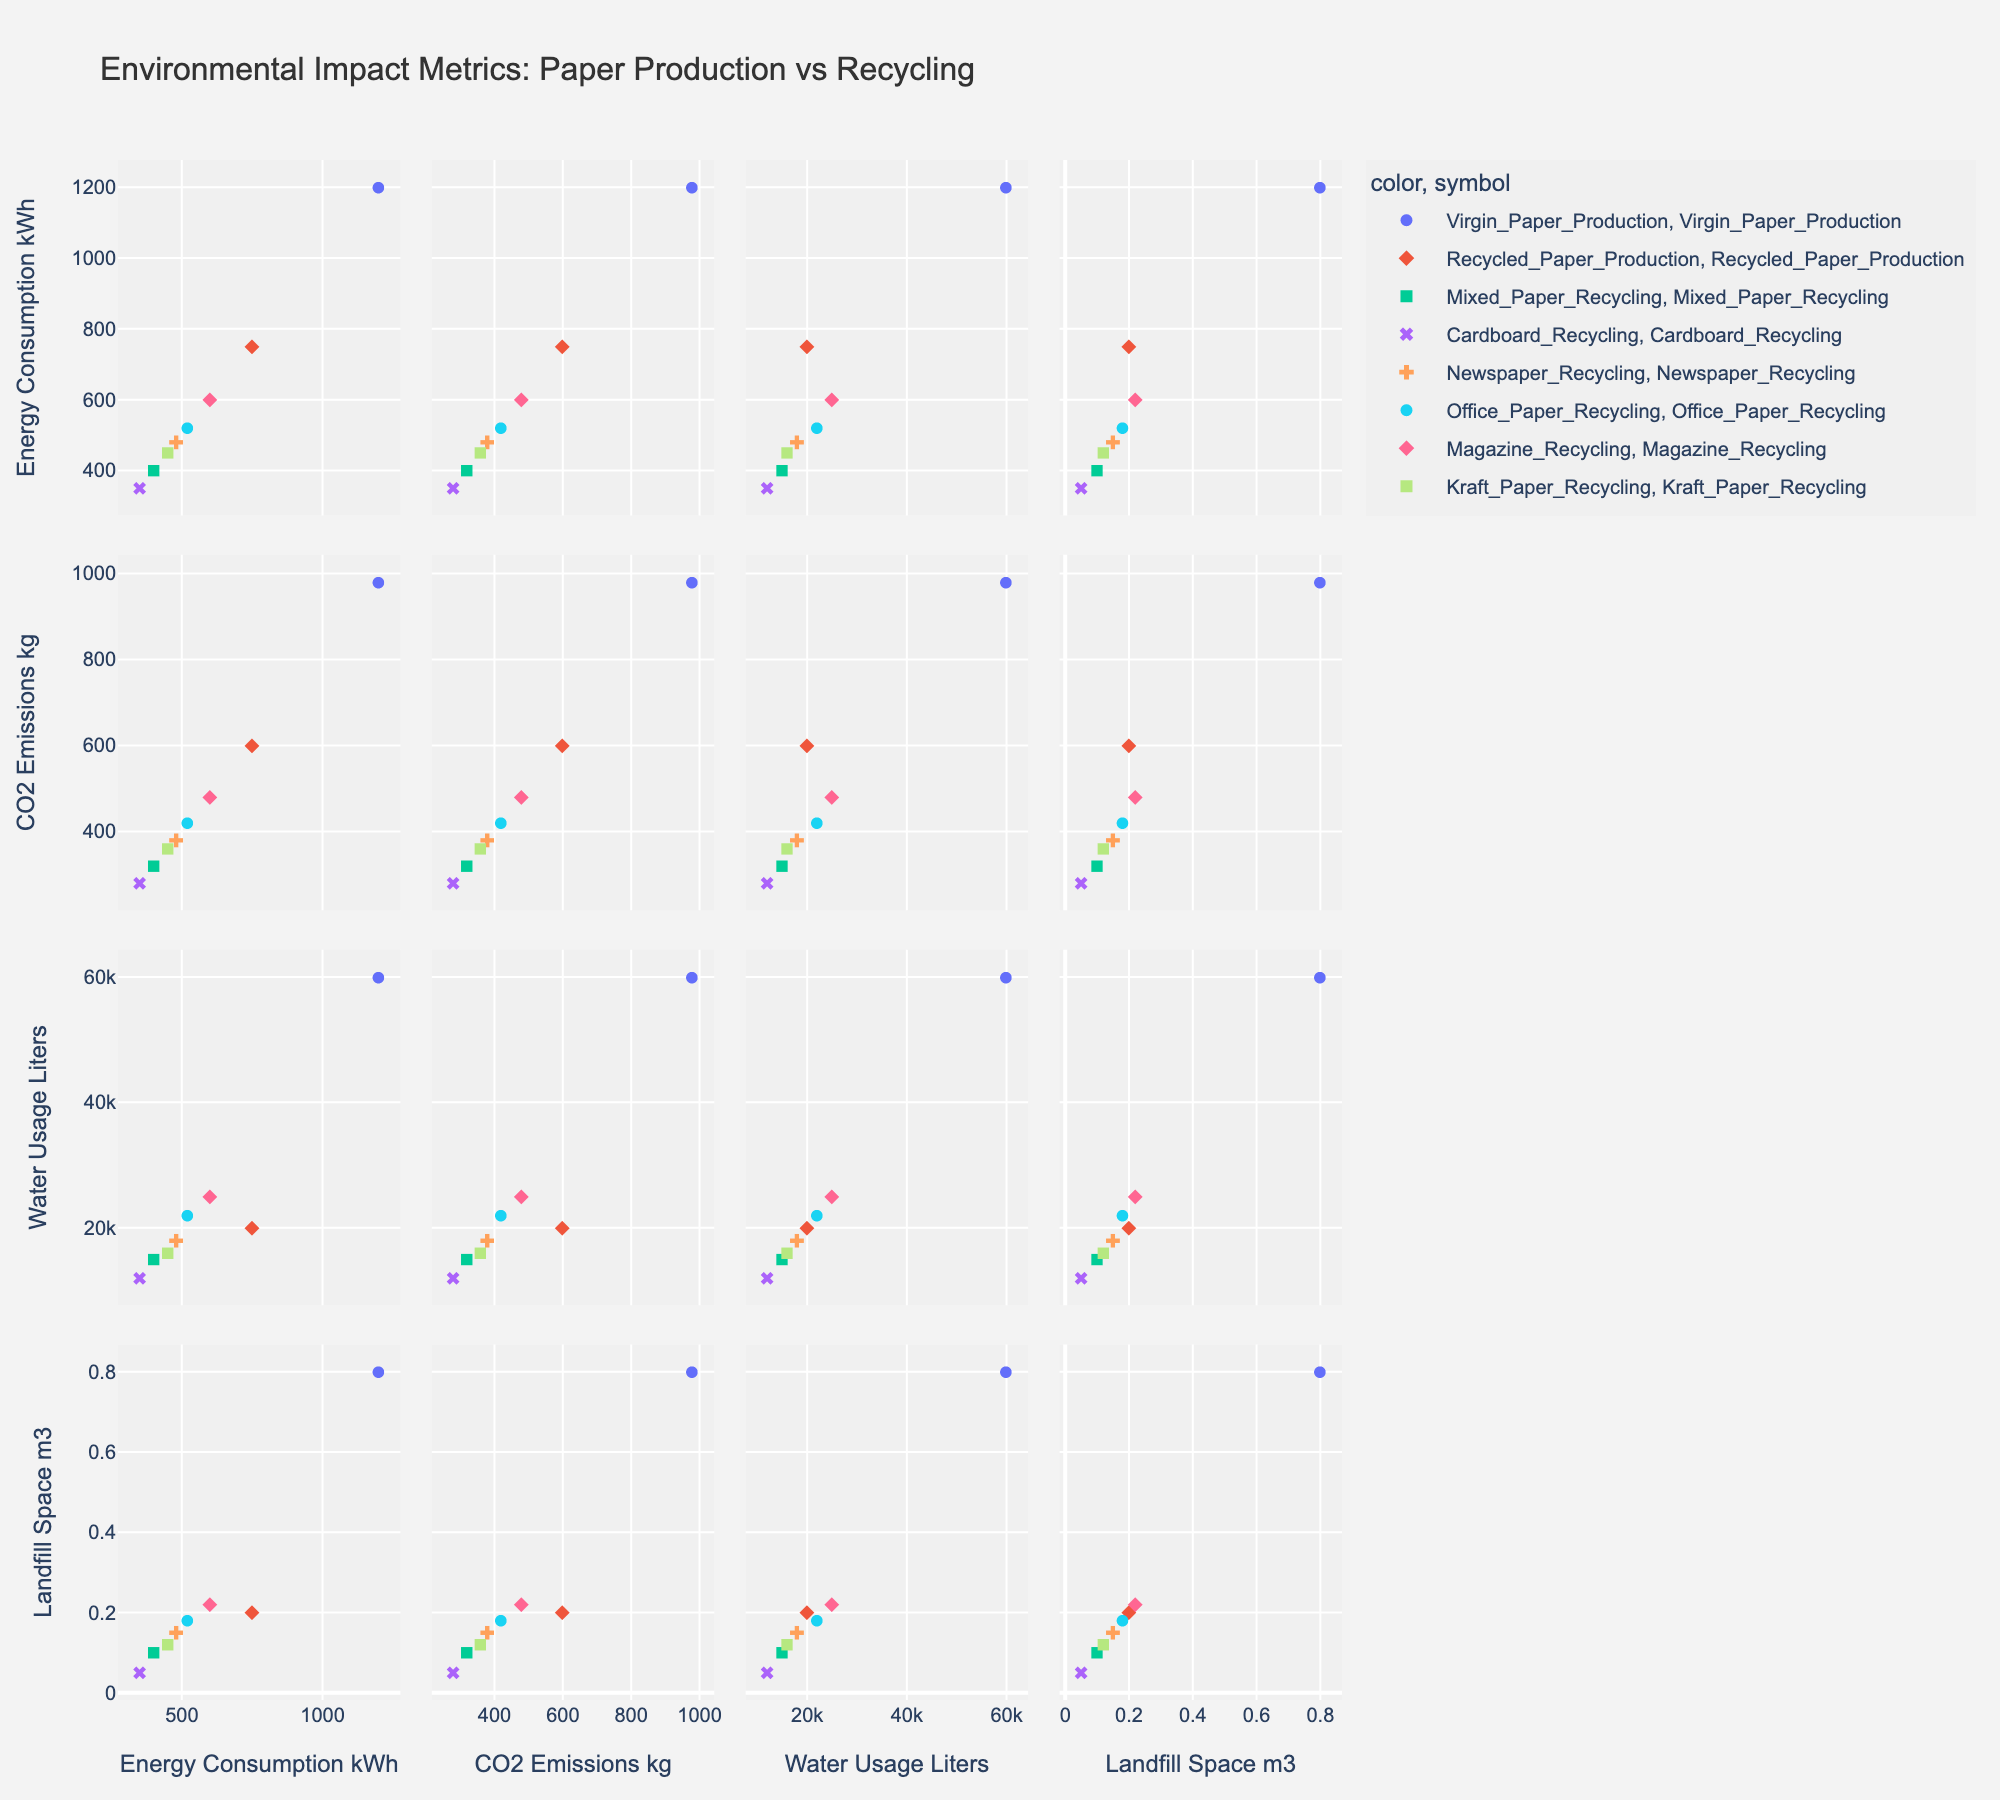What's the title of the scatterplot matrix? The title of the scatterplot matrix is typically located at the top of the figure, written in a prominent and larger font size. In this case, the title reads "Environmental Impact Metrics: Paper Production vs Recycling".
Answer: Environmental Impact Metrics: Paper Production vs Recycling How many different paper recycling processes are represented in the figure? To determine the number of different paper recycling processes, look at the legend where each process is listed with a color or symbol. The figure should include seven different recycling processes.
Answer: Seven Which process has the lowest energy consumption? Find the scatter plots related to energy consumption (y-axis) and check which point is at the lowest position. In this case, "Cardboard Recycling" has the lowest energy consumption.
Answer: Cardboard Recycling Between Virgin Paper Production and Mixed Paper Recycling, which process has higher CO2 emissions, and by how much? Locate the CO2 Emissions scatter plots and identify the points for Virgin Paper Production and Mixed Paper Recycling. Observe the y-values to compare. Virgin Paper Production has 980 kg CO2 emissions, and Mixed Paper Recycling has 320 kg. The difference is 980 - 320.
Answer: Virgin Paper Production by 660 kg What is the average water usage across all processes shown? Identify the water usage values for each process from the figure or data and then calculate the average. Summing these values (60000 + 20000 + 15000 + 12000 + 18000 + 22000 + 25000 + 16000) and dividing by the number of processes (8) gives the average.
Answer: 23500 Liters Which recycling process has the smallest environmental impact based on landfill space usage? Look at the plots related to Landfill Space (m3) and see which process has the data point closest to zero. This point belongs to "Cardboard Recycling" with 0.05 m3.
Answer: Cardboard Recycling By comparing Office Paper Recycling and Magazine Recycling, which has a higher water usage, and what is the difference in usage? From the Water Usage scatter plots, identify the points for Office Paper Recycling and Magazine Recycling. Office Paper Recycling uses 22000 liters and Magazine Recycling uses 25000 liters. The difference is 25000 - 22000.
Answer: Magazine Recycling by 3000 Liters What is the general trend between energy consumption and CO2 emissions for all processes shown? By examining scatter plots with Energy Consumption and CO2 Emissions axes, we can observe a positive correlation where higher energy consumption tends to accompany higher CO2 emissions across the processes.
Answer: Positive correlation Are any processes overlapping or very close to each other on any of the metrics? If yes, which ones and on what metrics? By carefully scrutinizing each scatter plot, you can identify the points that are very close to each other. For example, "Office Paper Recycling" and "Magazine Recycling" are close in terms of CO2 emissions and energy consumption.
Answer: Office Paper Recycling and Magazine Recycling on CO2 emissions and energy consumption Which process has the highest water usage among the recycled paper production processes? Look at the Water Usage scatter plots and focus on the points related to all recycled paper production processes except Virgin Paper. Identify the highest y-value point which belongs to "Magazine Recycling" at 25000 liters.
Answer: Magazine Recycling 